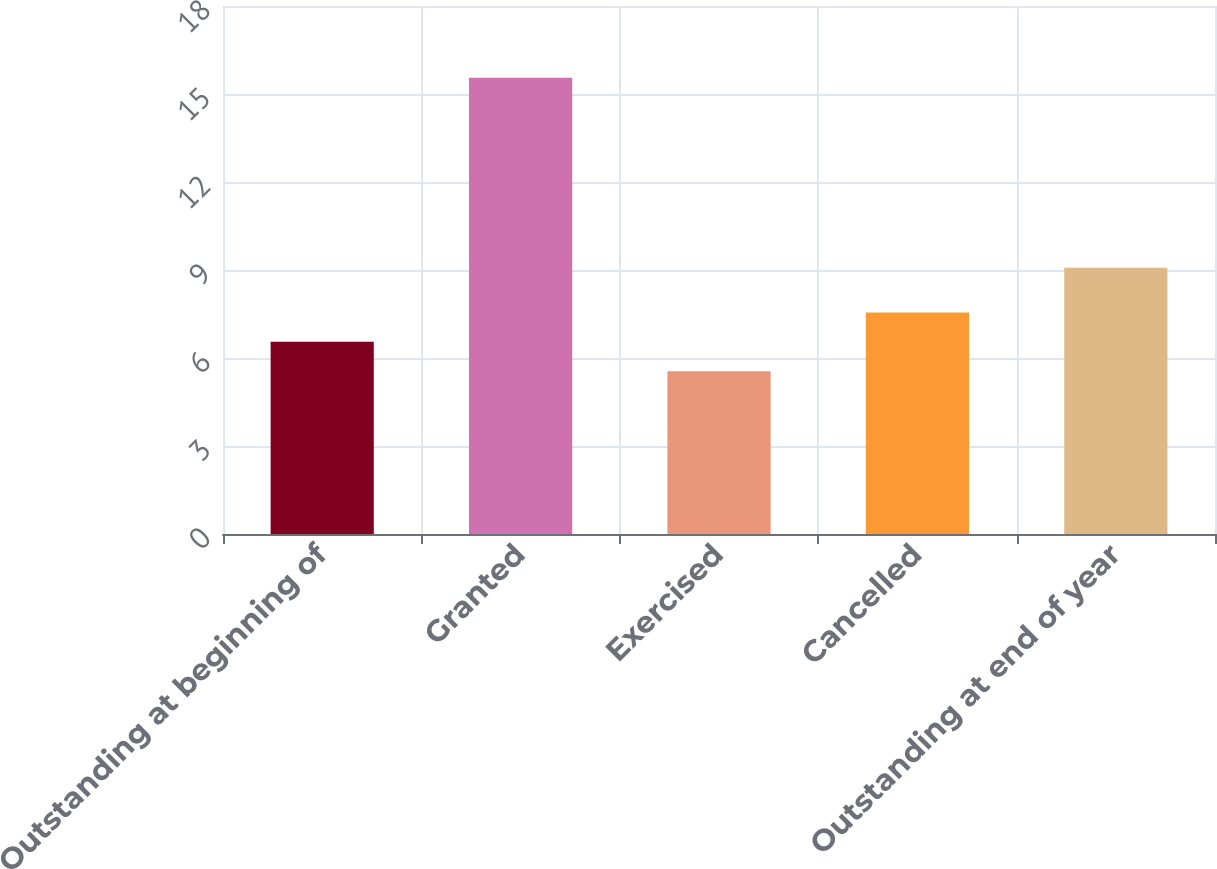Convert chart. <chart><loc_0><loc_0><loc_500><loc_500><bar_chart><fcel>Outstanding at beginning of<fcel>Granted<fcel>Exercised<fcel>Cancelled<fcel>Outstanding at end of year<nl><fcel>6.55<fcel>15.55<fcel>5.55<fcel>7.55<fcel>9.08<nl></chart> 